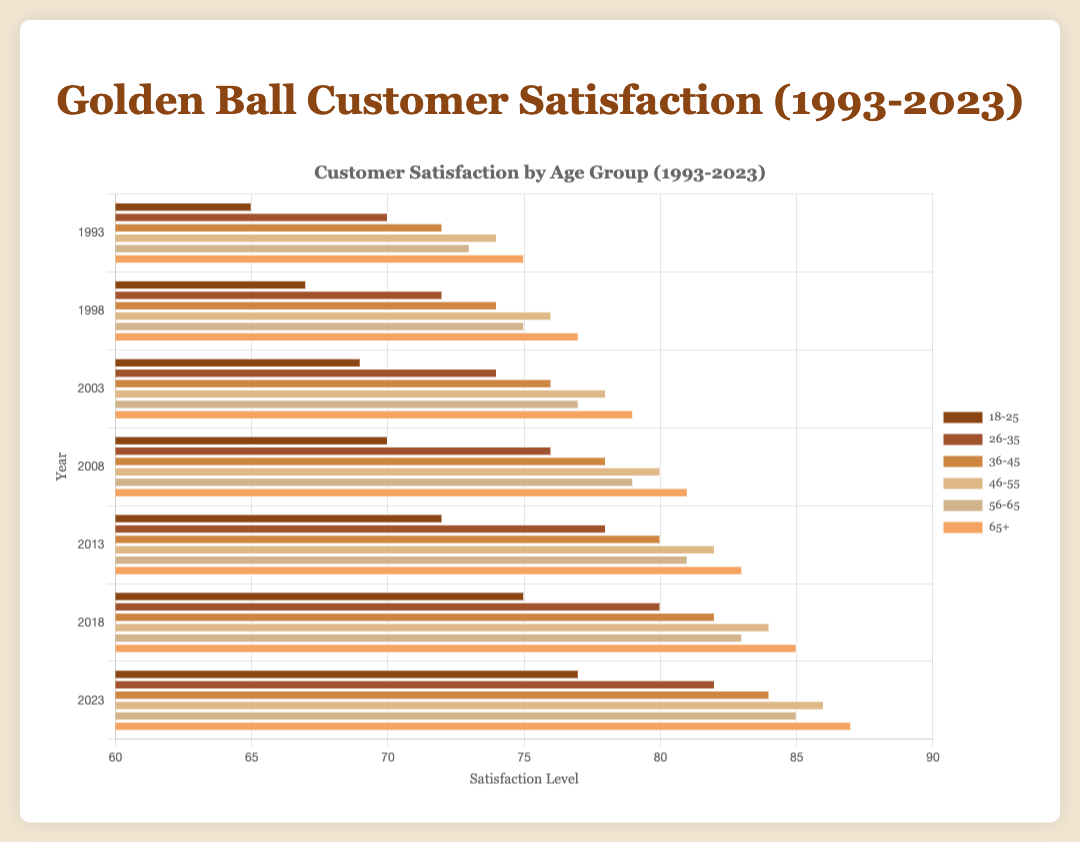what was the customer satisfaction level of the 36-45 age group in 2003? The chart shows the satisfaction level for each age group by year. For the year 2003 and the age group 36-45, the value is specifically shown.
Answer: 76 which age group had the highest satisfaction level in 2023? To find the highest satisfaction level, compare the values for each age group in 2023. The age group 65+ has the highest score.
Answer: 65+ how did the satisfaction level of 18-25 age group change from 1993 to 2023? Subtract the satisfaction level of 18-25 in 1993 from the satisfaction level in 2023 (77 - 65).
Answer: Increased by 12 is the satisfaction level of the 26-35 age group greater than the 46-55 age group in 2018? Compare the satisfaction levels for these two age groups in 2018. 26-35 has a level of 80 and 46-55 has 84, so 84 is greater.
Answer: No what is the average satisfaction level for the 56-65 age group across all years? Sum up the satisfaction levels for 56-65 for each year (73+75+77+79+81+83+85) and then divide by the number of years (7). (553 / 7) = 79
Answer: 79 which age group had the lowest satisfaction level in 1998? Find the smallest value among the satisfaction levels for the different age groups in 1998. The 18-25 age group has the lowest satisfaction level at 67.
Answer: 18-25 what is the total increase in satisfaction level for the 46-55 age group from 1993 to 2003? To get the total increase, subtract the 1993 level from the 2003 level (78 - 74 = 4).
Answer: Increased by 4 which age group shows the most consistent satisfaction level trend over the years? Look for the smallest or least varied changes in satisfaction levels over the years for any age group. The 56-65 age group has a gradually increasing trend from 73 to 85.
Answer: 56-65 which age group had a satisfaction level below 70 in 2008? Check each age group's satisfaction level for the year 2008. Only the 18-25 age group had a level at 70, so none were below 70.
Answer: None 